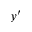<formula> <loc_0><loc_0><loc_500><loc_500>y ^ { \prime }</formula> 